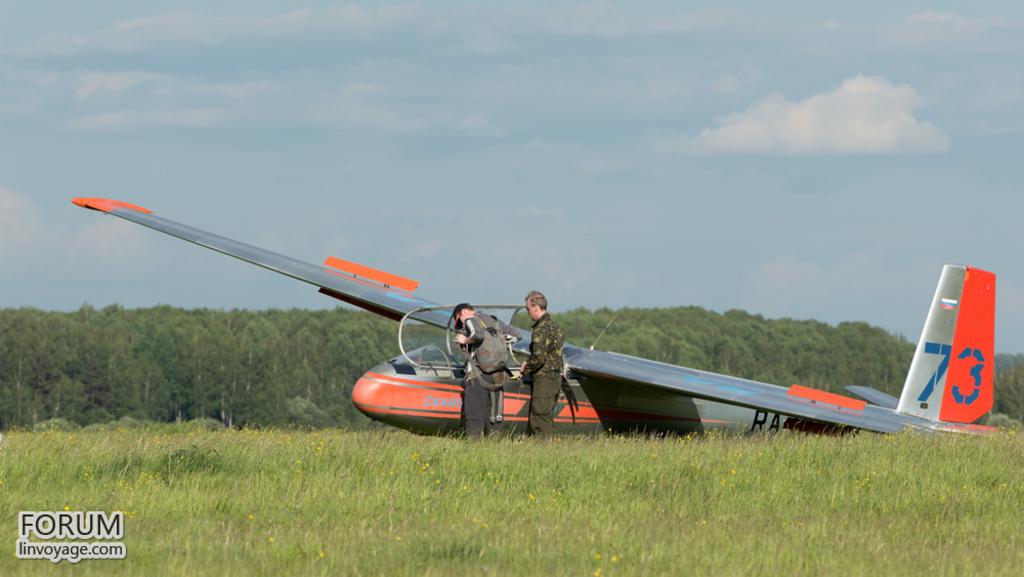What number is on the tail of the plane?
Provide a succinct answer. 73. 